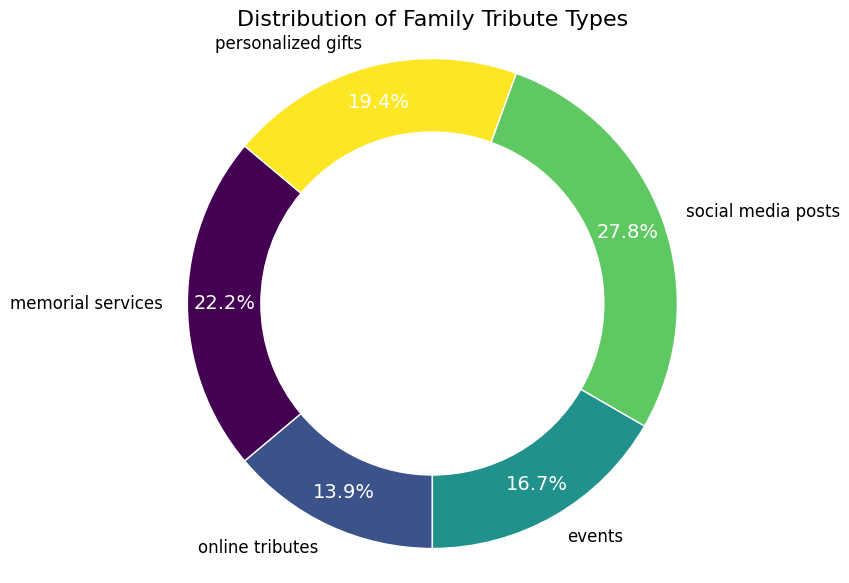What percentage of the tributes are social media posts? Social media posts account for 50 of the tributes. To find the percentage, divide the number of social media posts by the total number of tributes and multiply by 100. The total number of tributes is 40 + 25 + 30 + 50 + 35 = 180. Thus, the percentage is (50/180) * 100 ≈ 27.8%
Answer: 27.8% Which tribute type has the highest count? The tribute type with the highest count can be identified by looking at the largest section of the pie chart. Social media posts have the highest count with 50 tributes.
Answer: Social media posts How many more social media posts are there compared to online tributes? Social media posts are 50, and online tributes are 25. The difference is 50 - 25 = 25.
Answer: 25 Which tribute type has the smallest count? The smallest section on the pie chart represents the tribute type with the smallest count. Online tributes have the smallest count with 25 tributes.
Answer: Online tributes What is the combined percentage of personalized gifts and events? The counts for personalized gifts and events are 35 and 30 respectively. The total number of tributes is 180. The combined count is 35 + 30 = 65. The percentage is (65/180) * 100 ≈ 36.1%.
Answer: 36.1% Compare the count of memorial services to personalized gifts and determine if one is greater and by how much. Memorial services have a count of 40 and personalized gifts have a count of 35. Since 40 is greater than 35, the difference is 40 - 35 = 5.
Answer: 5 Are there more memorial services or events, and by how much? Memorial services have a count of 40, while events have a count of 30. Since 40 is greater than 30, the difference is 40 - 30 = 10.
Answer: 10 What is the combined count of all tributes except social media posts? The total count of tributes is 180. Social media posts account for 50. Subtracting 50 from 180 gives 180 - 50 = 130.
Answer: 130 What percentage of the total tributes do memorial services and social media posts together account for? Memorial services count is 40 and social media posts count is 50, combined they total 90. The total number of tributes is 180. The percentage is (90/180) * 100 = 50%.
Answer: 50% 